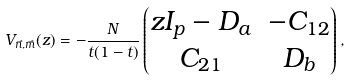<formula> <loc_0><loc_0><loc_500><loc_500>V _ { \vec { n } , \vec { m } } ( z ) = - \frac { N } { t ( 1 - t ) } \begin{pmatrix} z I _ { p } - D _ { a } & - C _ { 1 2 } \\ C _ { 2 1 } & D _ { b } \end{pmatrix} ,</formula> 